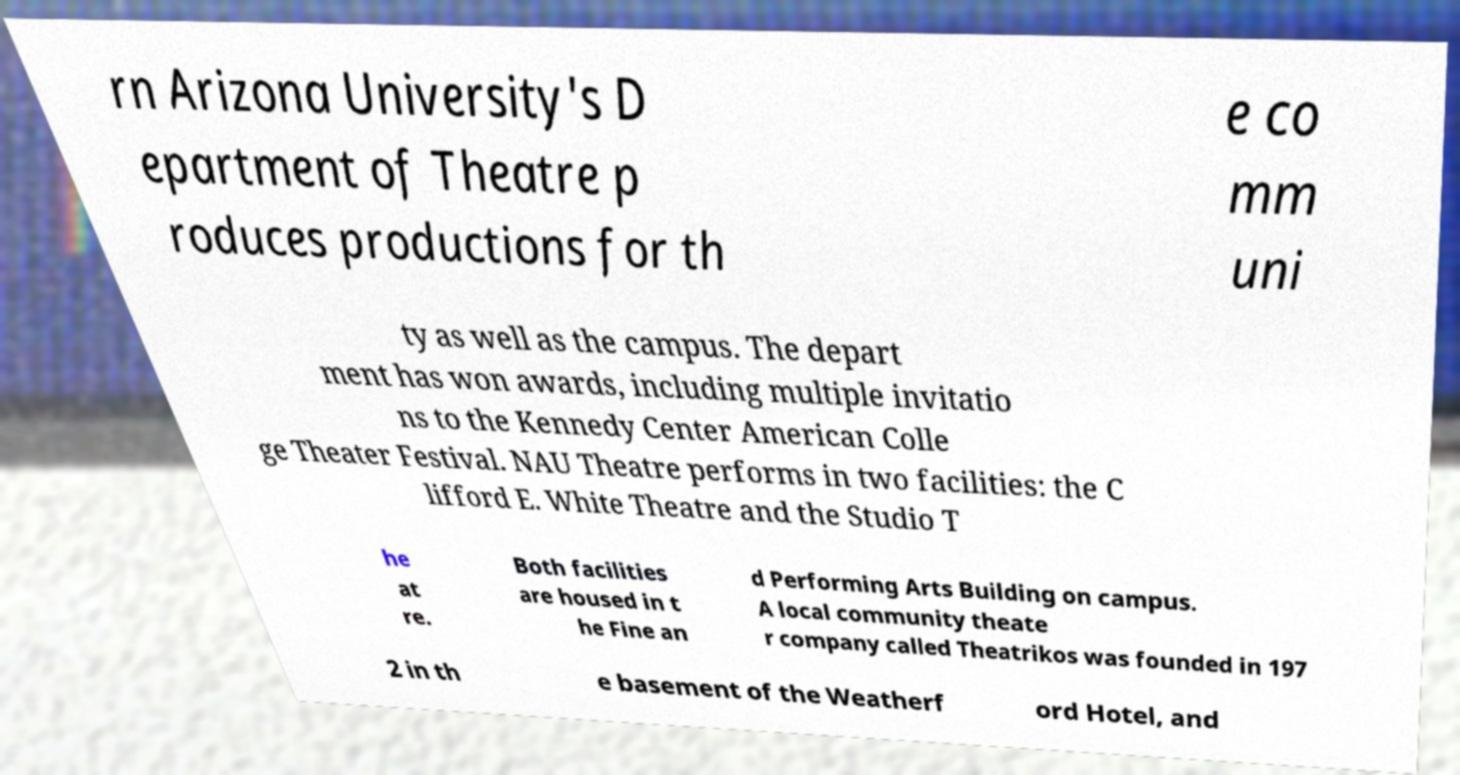I need the written content from this picture converted into text. Can you do that? rn Arizona University's D epartment of Theatre p roduces productions for th e co mm uni ty as well as the campus. The depart ment has won awards, including multiple invitatio ns to the Kennedy Center American Colle ge Theater Festival. NAU Theatre performs in two facilities: the C lifford E. White Theatre and the Studio T he at re. Both facilities are housed in t he Fine an d Performing Arts Building on campus. A local community theate r company called Theatrikos was founded in 197 2 in th e basement of the Weatherf ord Hotel, and 